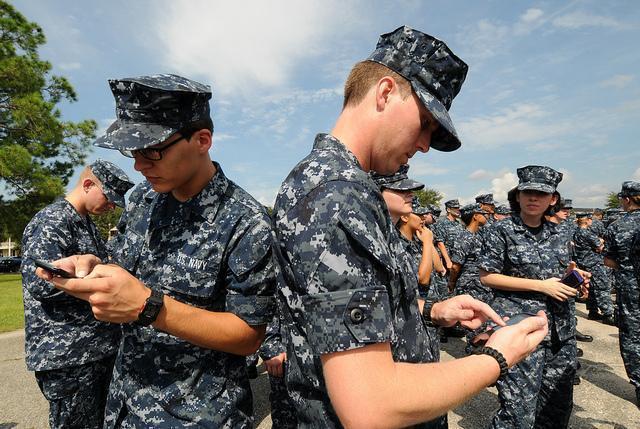How many people can be seen?
Give a very brief answer. 7. 